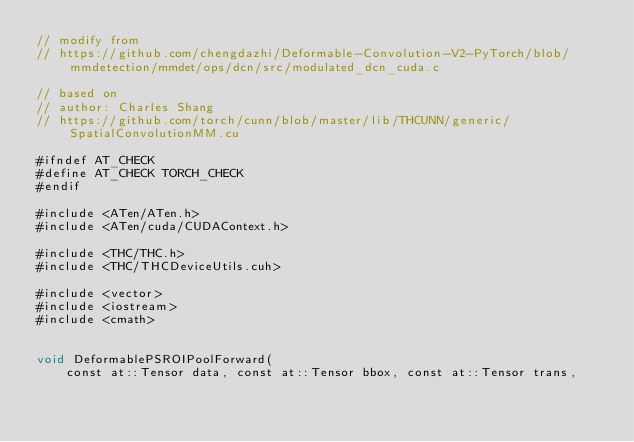Convert code to text. <code><loc_0><loc_0><loc_500><loc_500><_Cuda_>// modify from
// https://github.com/chengdazhi/Deformable-Convolution-V2-PyTorch/blob/mmdetection/mmdet/ops/dcn/src/modulated_dcn_cuda.c

// based on
// author: Charles Shang
// https://github.com/torch/cunn/blob/master/lib/THCUNN/generic/SpatialConvolutionMM.cu

#ifndef AT_CHECK
#define AT_CHECK TORCH_CHECK
#endif

#include <ATen/ATen.h>
#include <ATen/cuda/CUDAContext.h>

#include <THC/THC.h>
#include <THC/THCDeviceUtils.cuh>

#include <vector>
#include <iostream>
#include <cmath>


void DeformablePSROIPoolForward(
    const at::Tensor data, const at::Tensor bbox, const at::Tensor trans,</code> 